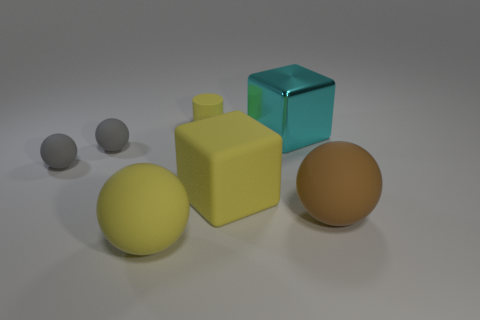Subtract all gray blocks. How many gray spheres are left? 2 Subtract all yellow balls. How many balls are left? 3 Subtract all yellow spheres. How many spheres are left? 3 Add 1 gray balls. How many objects exist? 8 Subtract all purple balls. Subtract all brown blocks. How many balls are left? 4 Subtract all spheres. How many objects are left? 3 Add 6 small gray matte cylinders. How many small gray matte cylinders exist? 6 Subtract 1 yellow cubes. How many objects are left? 6 Subtract all large brown objects. Subtract all brown things. How many objects are left? 5 Add 2 large yellow blocks. How many large yellow blocks are left? 3 